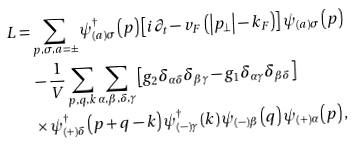<formula> <loc_0><loc_0><loc_500><loc_500>L = & \sum _ { p , \sigma , a = \pm } \psi _ { ( a ) \sigma } ^ { \dagger } \left ( p \right ) \left [ i \partial _ { t } - v _ { F } \left ( \left | p _ { \perp } \right | - k _ { F } \right ) \right ] \psi _ { ( a ) \sigma } \left ( p \right ) \\ & - \frac { 1 } { V } \sum _ { p , q , k } \sum _ { \alpha , \beta , \delta , \gamma } \left [ g _ { 2 } \delta _ { \alpha \delta } \delta _ { \beta \gamma } - g _ { 1 } \delta _ { \alpha \gamma } \delta _ { \beta \delta } \right ] \\ & \times \psi _ { \left ( + \right ) \delta } ^ { \dagger } \left ( p + q - k \right ) \psi _ { \left ( - \right ) \gamma } ^ { \dagger } \left ( k \right ) \psi _ { \left ( - \right ) \beta } \left ( q \right ) \psi _ { \left ( + \right ) \alpha } \left ( p \right ) , \\</formula> 